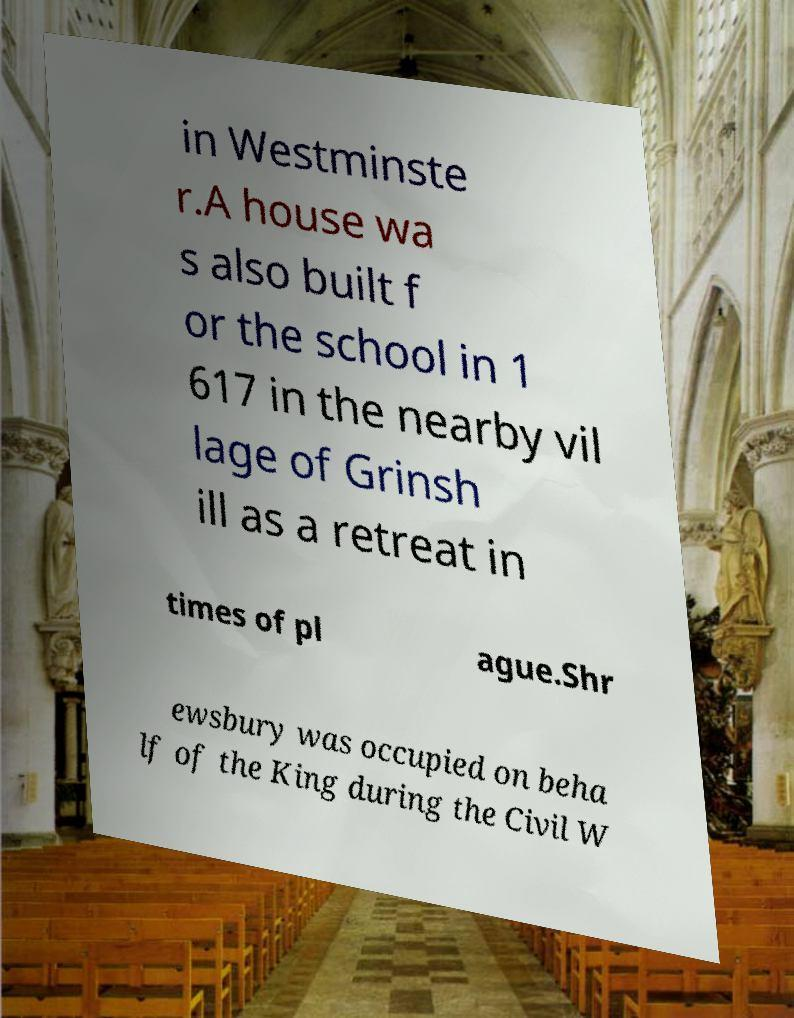Please identify and transcribe the text found in this image. in Westminste r.A house wa s also built f or the school in 1 617 in the nearby vil lage of Grinsh ill as a retreat in times of pl ague.Shr ewsbury was occupied on beha lf of the King during the Civil W 